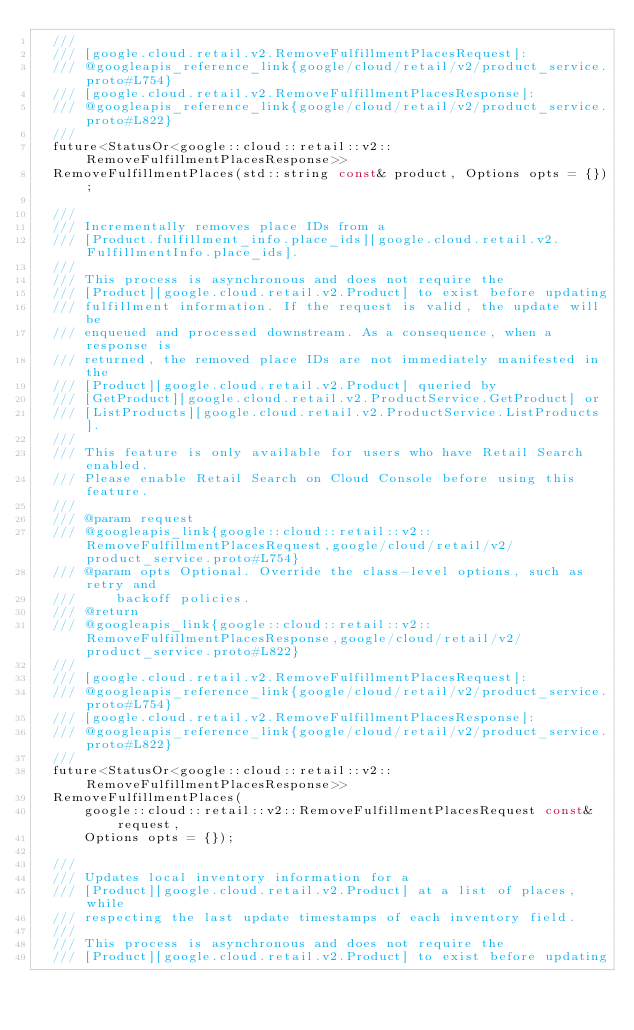<code> <loc_0><loc_0><loc_500><loc_500><_C_>  ///
  /// [google.cloud.retail.v2.RemoveFulfillmentPlacesRequest]:
  /// @googleapis_reference_link{google/cloud/retail/v2/product_service.proto#L754}
  /// [google.cloud.retail.v2.RemoveFulfillmentPlacesResponse]:
  /// @googleapis_reference_link{google/cloud/retail/v2/product_service.proto#L822}
  ///
  future<StatusOr<google::cloud::retail::v2::RemoveFulfillmentPlacesResponse>>
  RemoveFulfillmentPlaces(std::string const& product, Options opts = {});

  ///
  /// Incrementally removes place IDs from a
  /// [Product.fulfillment_info.place_ids][google.cloud.retail.v2.FulfillmentInfo.place_ids].
  ///
  /// This process is asynchronous and does not require the
  /// [Product][google.cloud.retail.v2.Product] to exist before updating
  /// fulfillment information. If the request is valid, the update will be
  /// enqueued and processed downstream. As a consequence, when a response is
  /// returned, the removed place IDs are not immediately manifested in the
  /// [Product][google.cloud.retail.v2.Product] queried by
  /// [GetProduct][google.cloud.retail.v2.ProductService.GetProduct] or
  /// [ListProducts][google.cloud.retail.v2.ProductService.ListProducts].
  ///
  /// This feature is only available for users who have Retail Search enabled.
  /// Please enable Retail Search on Cloud Console before using this feature.
  ///
  /// @param request
  /// @googleapis_link{google::cloud::retail::v2::RemoveFulfillmentPlacesRequest,google/cloud/retail/v2/product_service.proto#L754}
  /// @param opts Optional. Override the class-level options, such as retry and
  ///     backoff policies.
  /// @return
  /// @googleapis_link{google::cloud::retail::v2::RemoveFulfillmentPlacesResponse,google/cloud/retail/v2/product_service.proto#L822}
  ///
  /// [google.cloud.retail.v2.RemoveFulfillmentPlacesRequest]:
  /// @googleapis_reference_link{google/cloud/retail/v2/product_service.proto#L754}
  /// [google.cloud.retail.v2.RemoveFulfillmentPlacesResponse]:
  /// @googleapis_reference_link{google/cloud/retail/v2/product_service.proto#L822}
  ///
  future<StatusOr<google::cloud::retail::v2::RemoveFulfillmentPlacesResponse>>
  RemoveFulfillmentPlaces(
      google::cloud::retail::v2::RemoveFulfillmentPlacesRequest const& request,
      Options opts = {});

  ///
  /// Updates local inventory information for a
  /// [Product][google.cloud.retail.v2.Product] at a list of places, while
  /// respecting the last update timestamps of each inventory field.
  ///
  /// This process is asynchronous and does not require the
  /// [Product][google.cloud.retail.v2.Product] to exist before updating</code> 